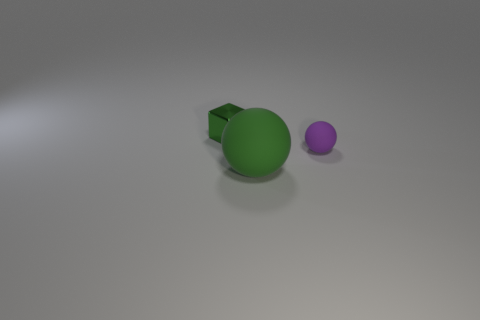How many big matte things have the same color as the tiny metallic thing?
Provide a short and direct response. 1. There is a ball that is the same size as the green metallic block; what color is it?
Offer a terse response. Purple. Is the material of the green thing that is in front of the tiny metal cube the same as the small object that is in front of the block?
Provide a succinct answer. Yes. There is a thing right of the green thing to the right of the small green shiny cube; what is its size?
Offer a very short reply. Small. What is the material of the small thing in front of the tiny block?
Offer a terse response. Rubber. What number of things are green things that are behind the small purple rubber ball or things to the right of the big matte sphere?
Keep it short and to the point. 2. There is another object that is the same shape as the large green object; what is it made of?
Make the answer very short. Rubber. There is a ball in front of the purple rubber ball; is it the same color as the tiny object that is in front of the small shiny block?
Offer a very short reply. No. Is there a red object of the same size as the green matte ball?
Offer a terse response. No. The thing that is behind the green rubber object and in front of the small green shiny block is made of what material?
Offer a terse response. Rubber. 